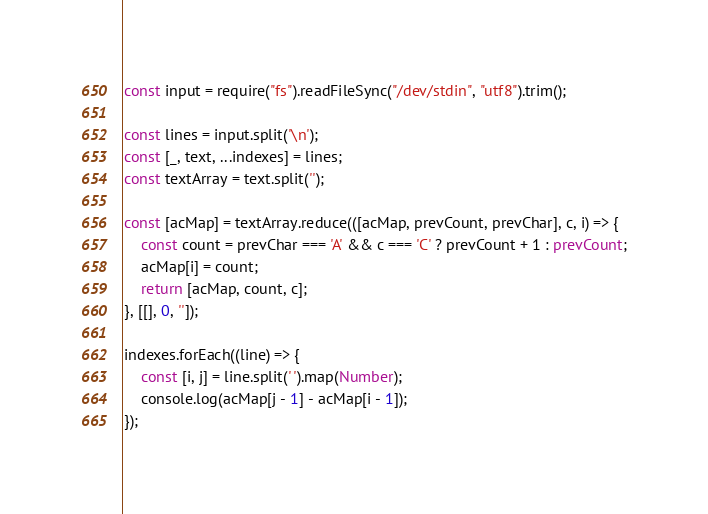<code> <loc_0><loc_0><loc_500><loc_500><_TypeScript_>const input = require("fs").readFileSync("/dev/stdin", "utf8").trim();

const lines = input.split('\n');
const [_, text, ...indexes] = lines;
const textArray = text.split('');

const [acMap] = textArray.reduce(([acMap, prevCount, prevChar], c, i) => {
    const count = prevChar === 'A' && c === 'C' ? prevCount + 1 : prevCount;
    acMap[i] = count;
    return [acMap, count, c];
}, [[], 0, '']);

indexes.forEach((line) => {
    const [i, j] = line.split(' ').map(Number);
    console.log(acMap[j - 1] - acMap[i - 1]);
});
</code> 